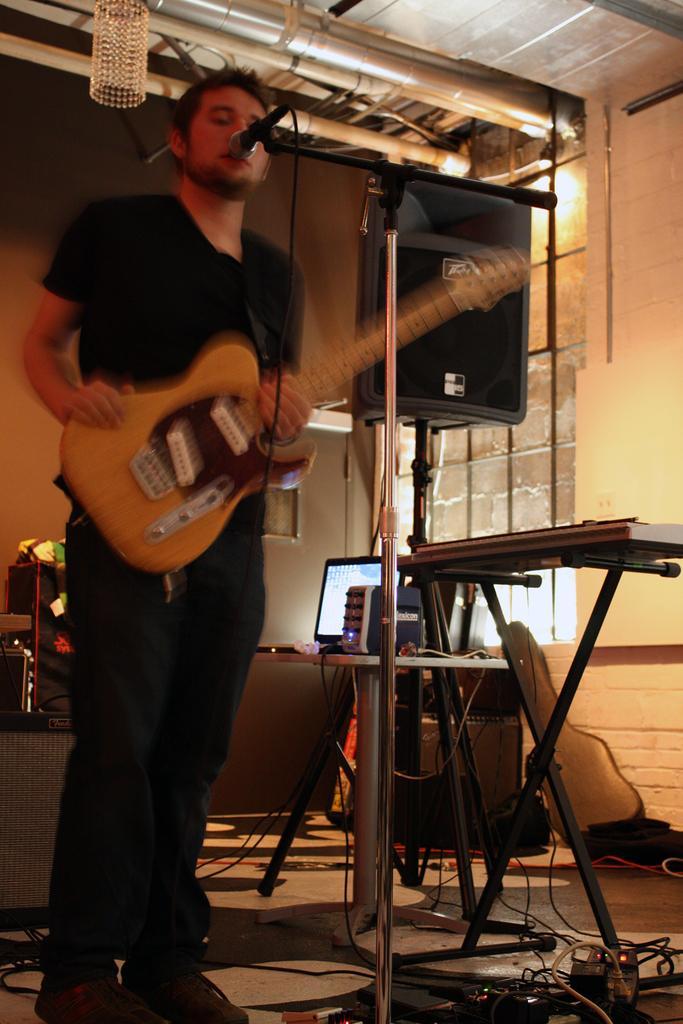Could you give a brief overview of what you see in this image? In this picture there is a man standing, holding the guitar in his hand and he is singing. There is a microphone in front of him. 